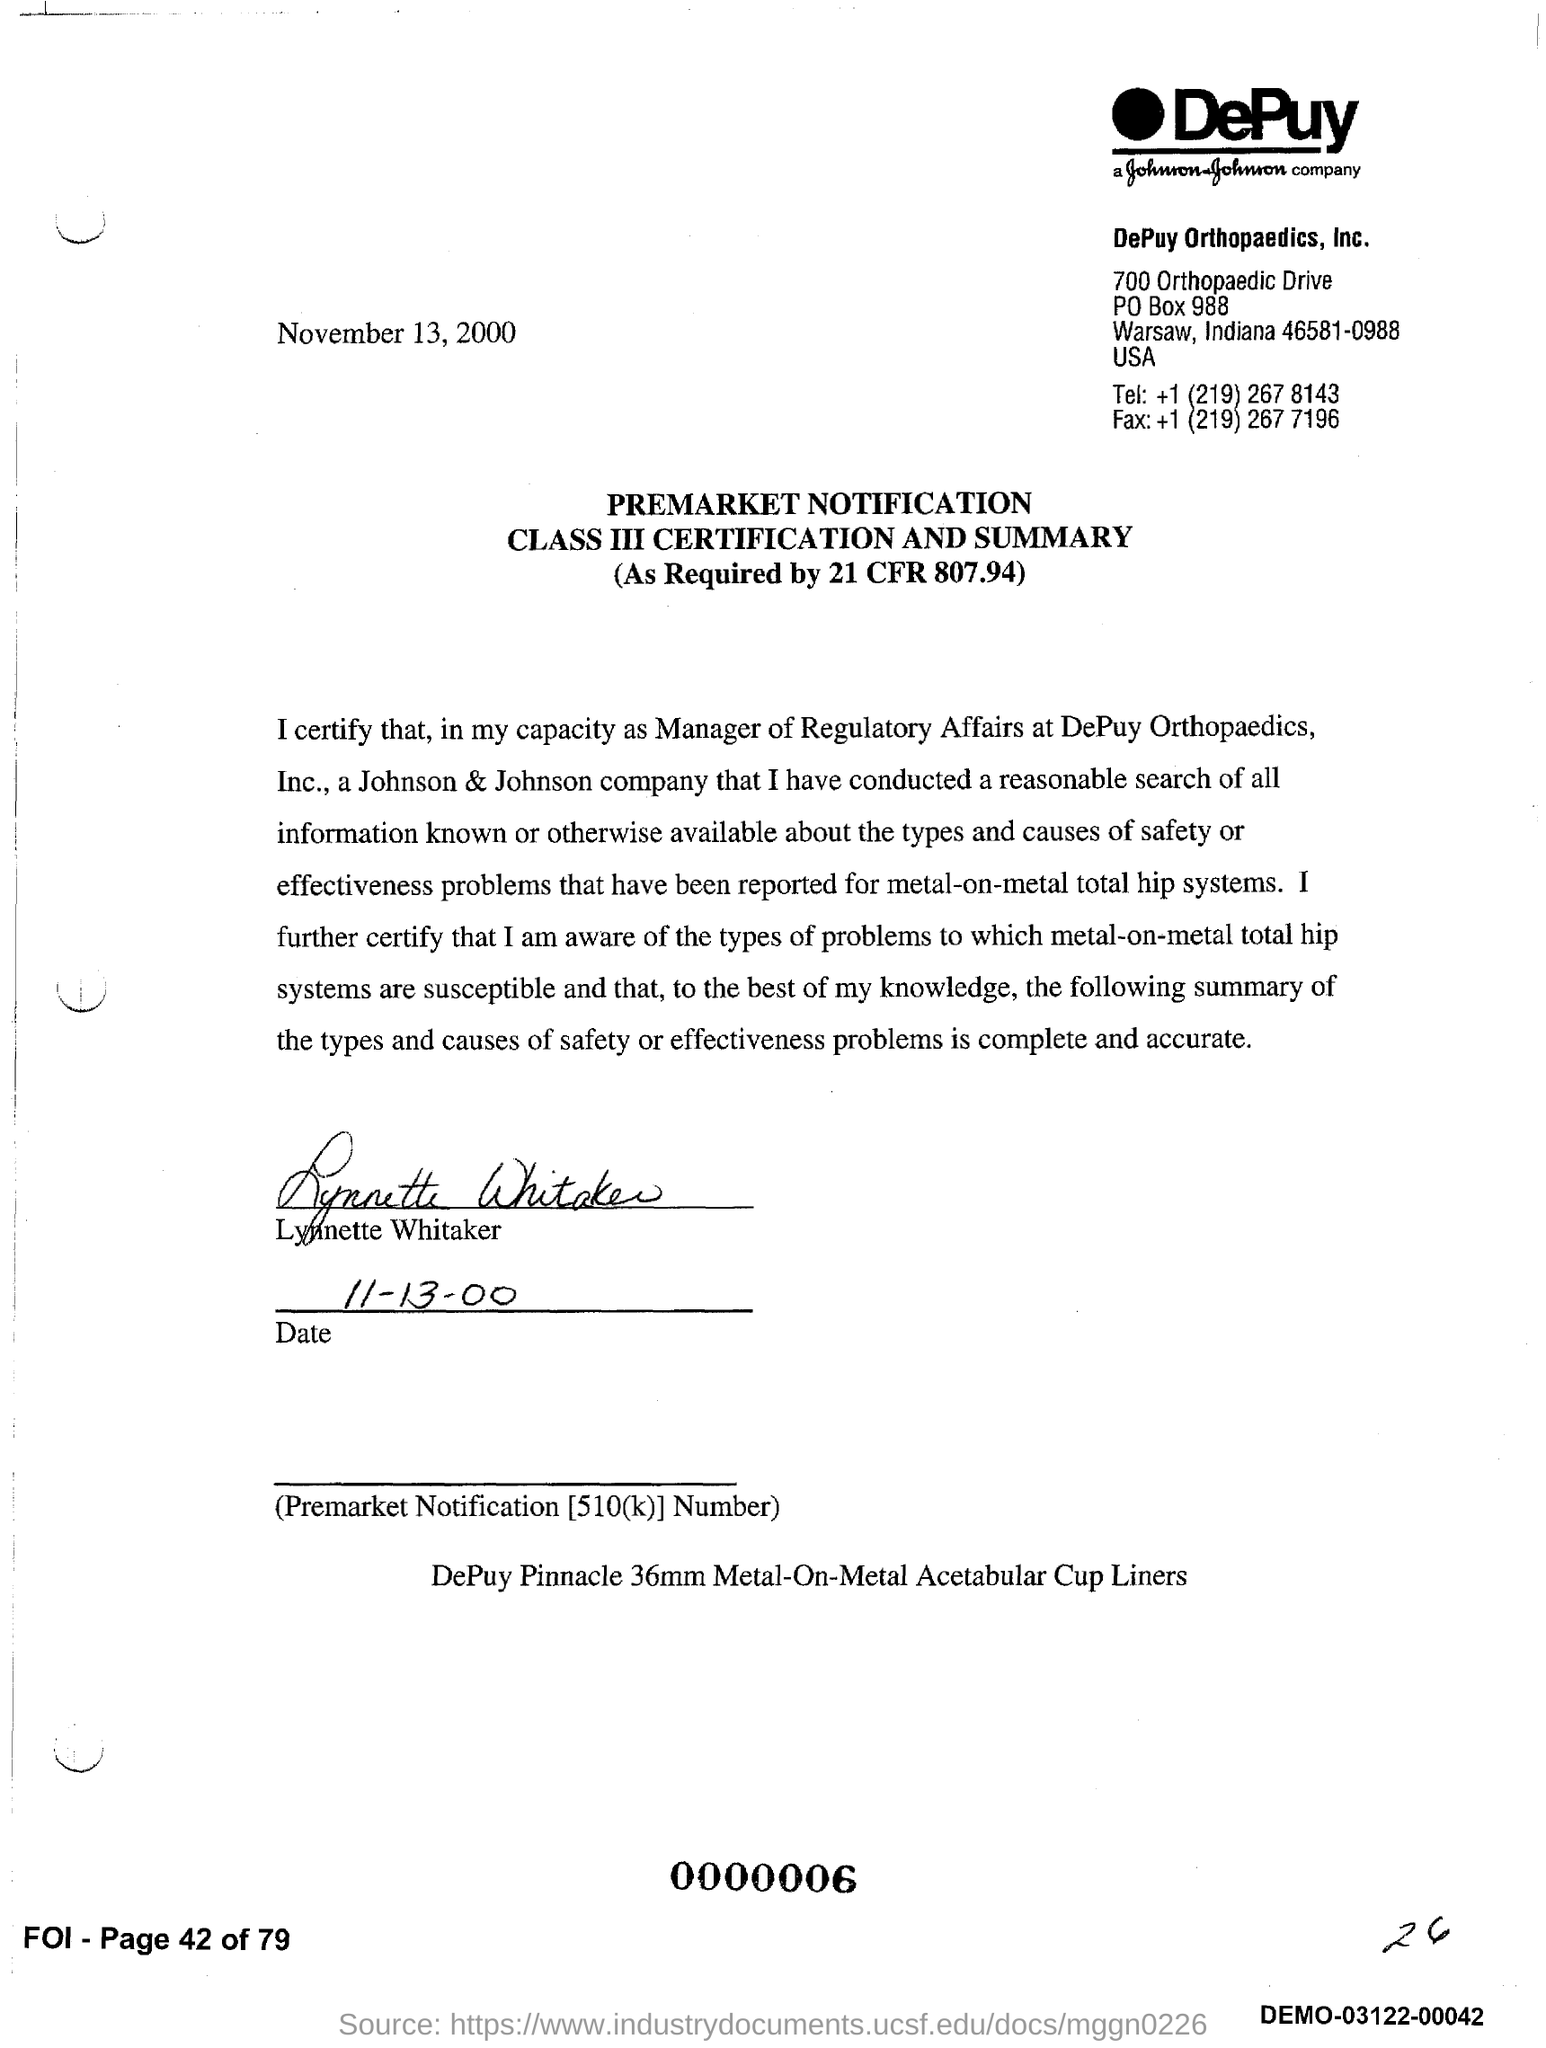Mention a couple of crucial points in this snapshot. The notification has been signed by Lynnette Whitaker. The signature date given in the notification is 11-13-00. 